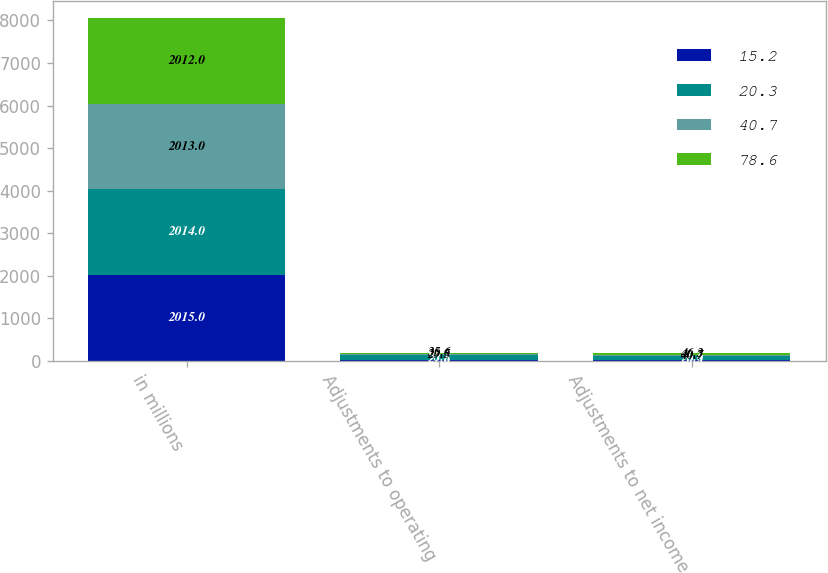Convert chart to OTSL. <chart><loc_0><loc_0><loc_500><loc_500><stacked_bar_chart><ecel><fcel>in millions<fcel>Adjustments to operating<fcel>Adjustments to net income<nl><fcel>15.2<fcel>2015<fcel>27.6<fcel>20.3<nl><fcel>20.3<fcel>2014<fcel>98.3<fcel>78.6<nl><fcel>40.7<fcel>2013<fcel>29.5<fcel>40.7<nl><fcel>78.6<fcel>2012<fcel>35.6<fcel>46.3<nl></chart> 